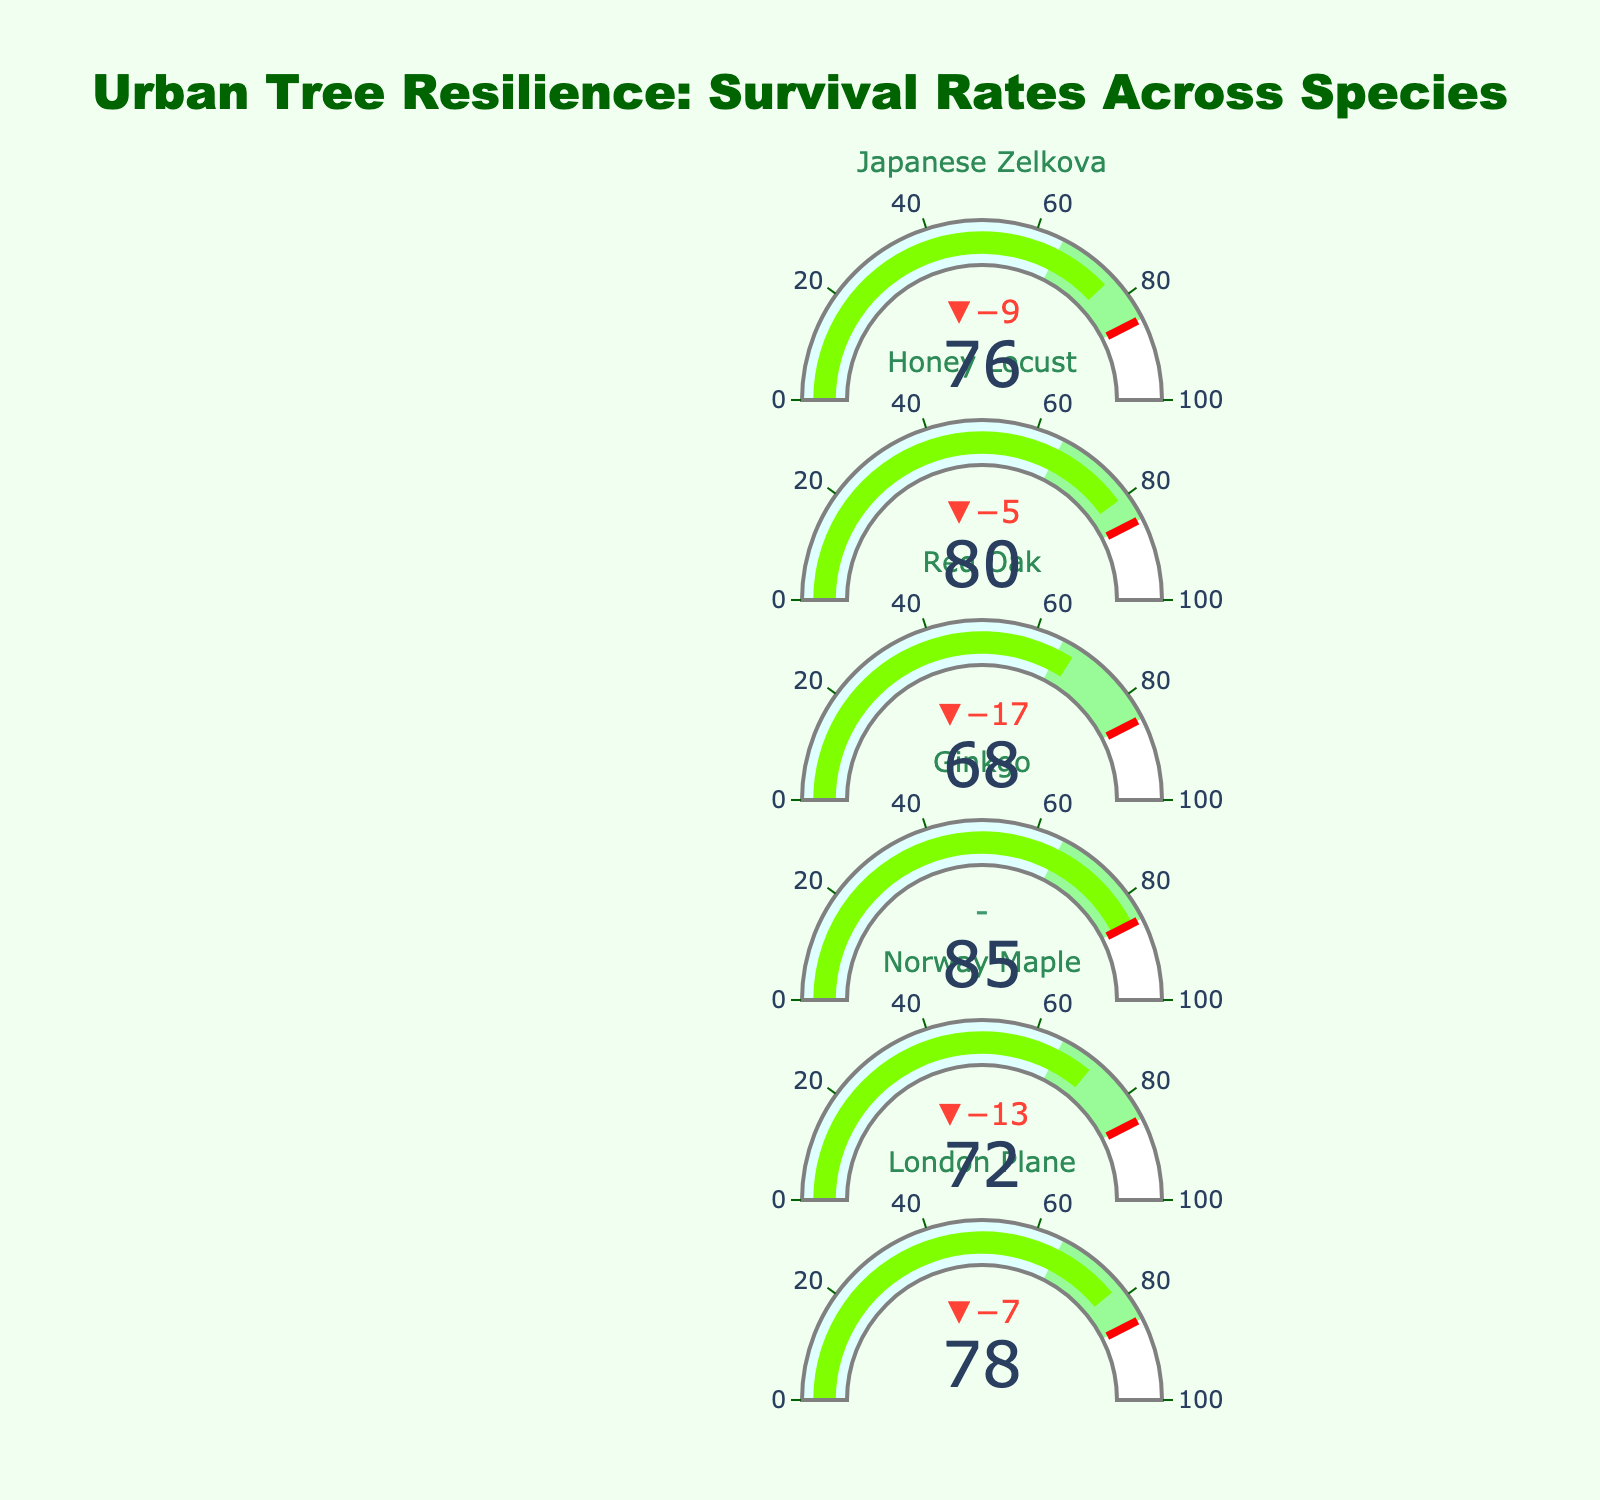What's the title of the chart? The title of the chart is located at the top center and reads "Urban Tree Resilience: Survival Rates Across Species".
Answer: Urban Tree Resilience: Survival Rates Across Species Which tree species has the highest survival rate? By examining the "Survival Rate (%)" values displayed for each tree species, Ginkgo shows the highest survival rate at 85%.
Answer: Ginkgo What color represents the threshold level for survival rates? The threshold level is indicated by a line which is colored in red.
Answer: Red How much higher is the survival rate of London Plane compared to the Red Oak? London Plane has a survival rate of 78%, and Red Oak has 68%. The difference is calculated by subtracting the survival rate of Red Oak from London Plane (78% - 68% = 10%).
Answer: 10% Are there any tree species that meet the target survival rate? To determine this, we look at the survival rates and compare them with the target rate of 85%. Only Ginkgo meets the target with a survival rate of 85%.
Answer: Ginkgo Which tree species has the lowest survival rate? By scanning the survival rates, Red Oak has the lowest survival rate at 68%.
Answer: Red Oak Is the survival rate of Honey Locust above the average city rate? Comparing Honey Locust's survival rate (80%) to the average city rate (65%), Honey Locust is above the average.
Answer: Yes How many tree species have survival rates above 75%? Counting the species with survival rates above 75%: London Plane (78%), Norway Maple (72%, not above 75), Ginkgo (85%), Red Oak (68%, not above 75), Honey Locust (80%), Japanese Zelkova (76%). This accounts for four species.
Answer: 4 Which tree species have survival rates within the range between the average city rate and the target rate? The range between the average city rate (65%) and the target rate (85%) includes Norway Maple (72%), London Plane (78%), Japanese Zelkova (76%). These species fall within this range.
Answer: Norway Maple, London Plane, Japanese Zelkova What is the difference between the average survival rate of all tree species and the average city rate? First, calculate the average survival rate: (78% + 72% + 85% + 68% + 80% + 76%) / 6 = 76.5%. Then subtract the average city rate: 76.5% - 65% = 11.5%.
Answer: 11.5% 